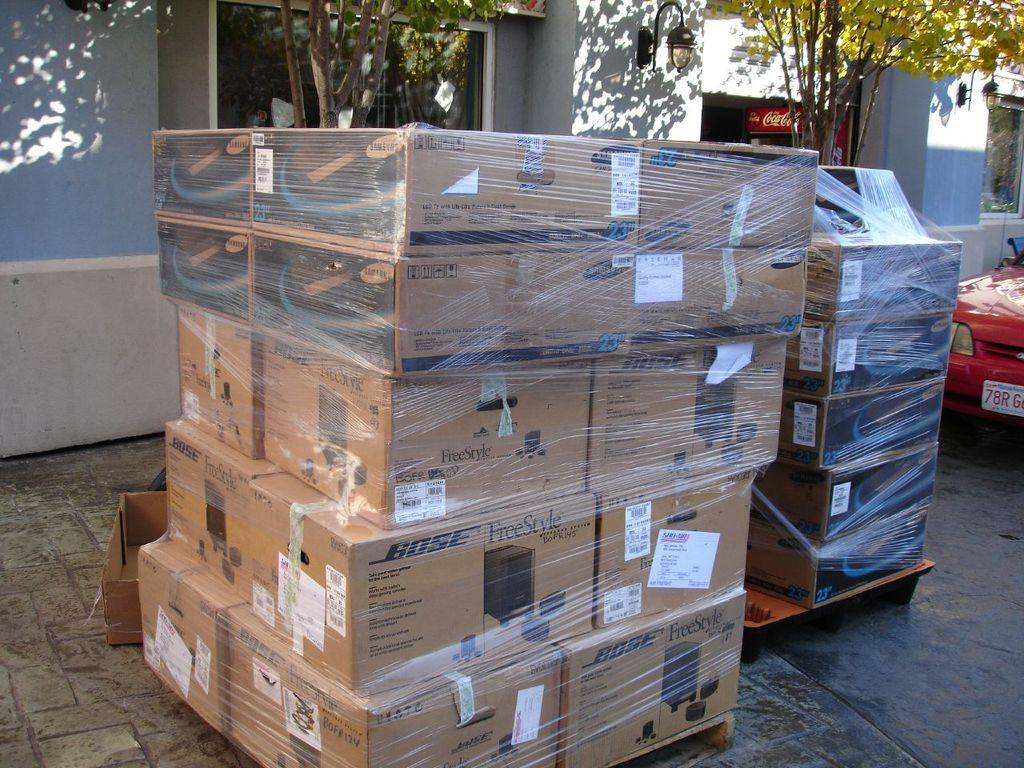<image>
Render a clear and concise summary of the photo. A pallet of boxes containing Bose products are shown outside. 